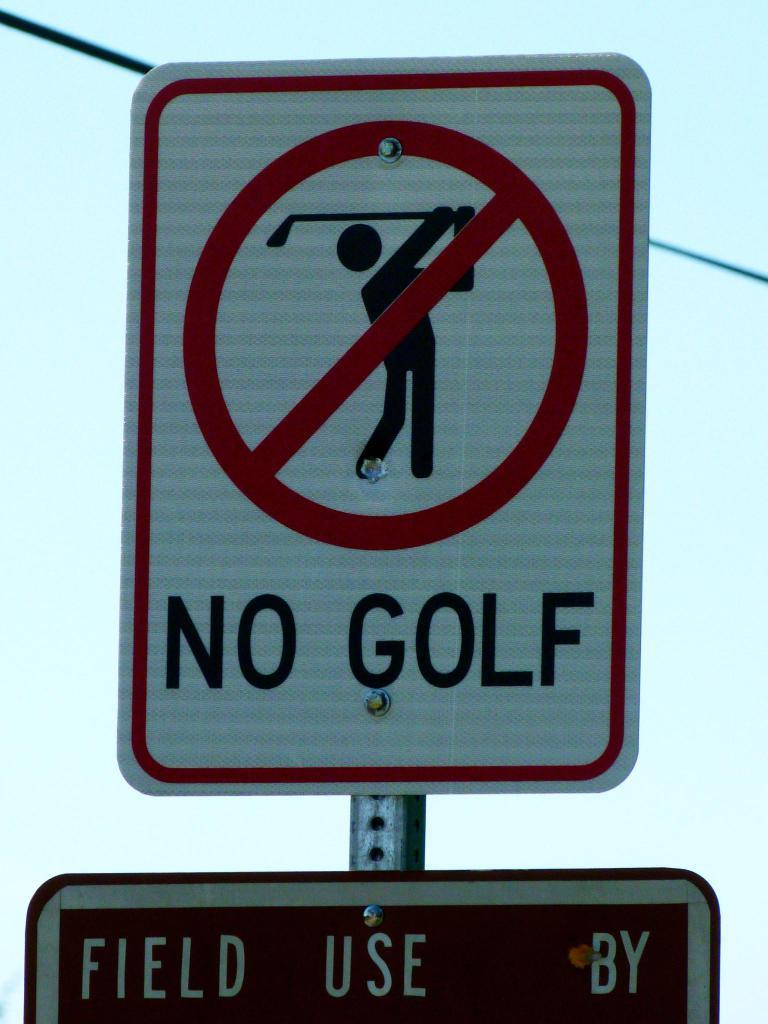What three words are seen on the green sign below?
Offer a terse response. Field use by. 